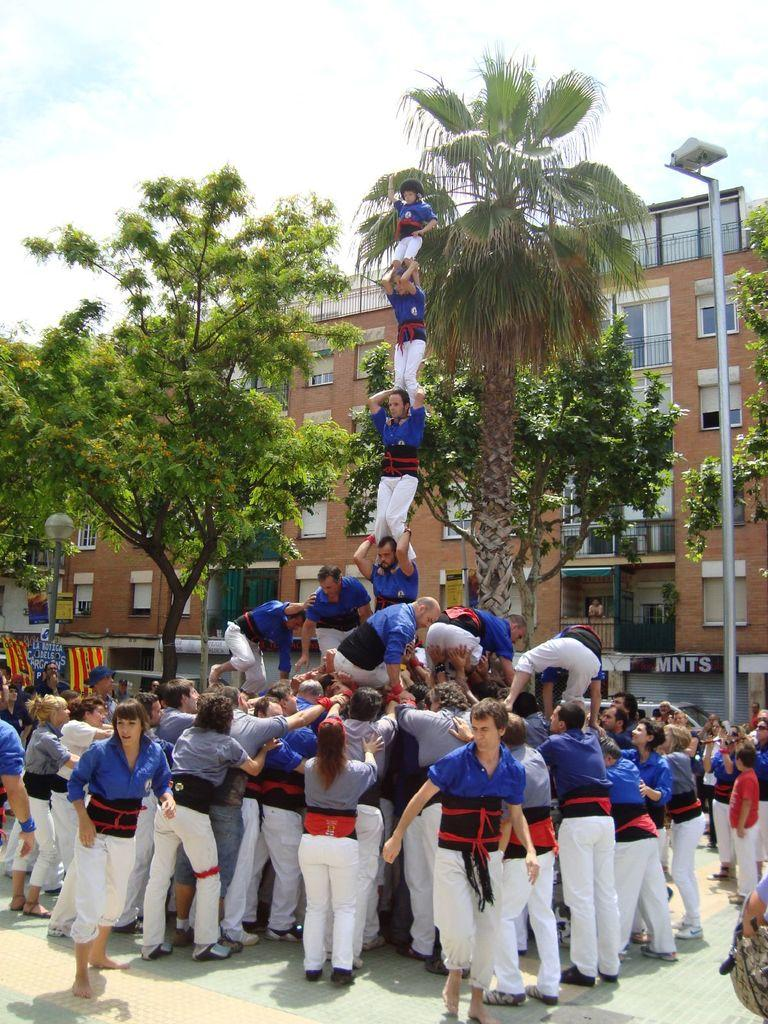How many people are in the image? There are many people in the image. What are the people doing in the image? The people are performing a stunt. What can be seen in the background of the image? There are trees and a building in the background of the image. What is located on the left side of the image? There is a light pole on the left side of the image. Are there any plantations visible in the image? There is no mention of a plantation in the image; it features people performing a stunt with a background of trees and a building. How many chickens can be seen in the image? There are no chickens present in the image. 